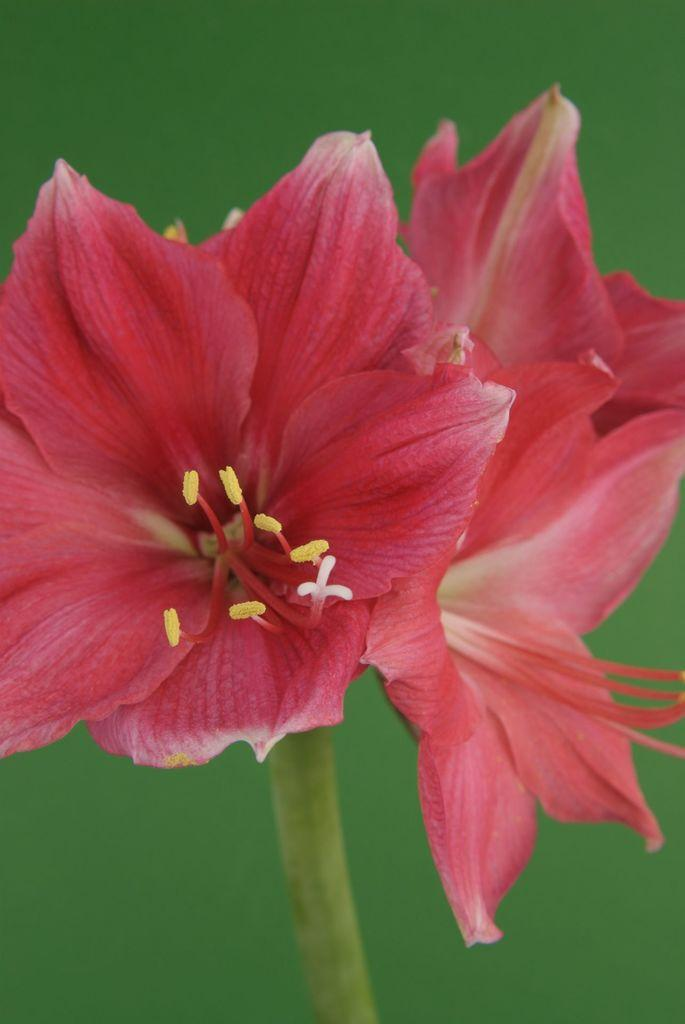What type of living organisms can be seen in the image? There are flowers in the image. What is the color of the flowers in the image? The flowers are red in color. What type of music can be heard coming from the wilderness in the image? There is no reference to music or wilderness in the image, so it's not possible to determine what, if any, music might be heard. 